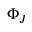Convert formula to latex. <formula><loc_0><loc_0><loc_500><loc_500>\Phi _ { J }</formula> 